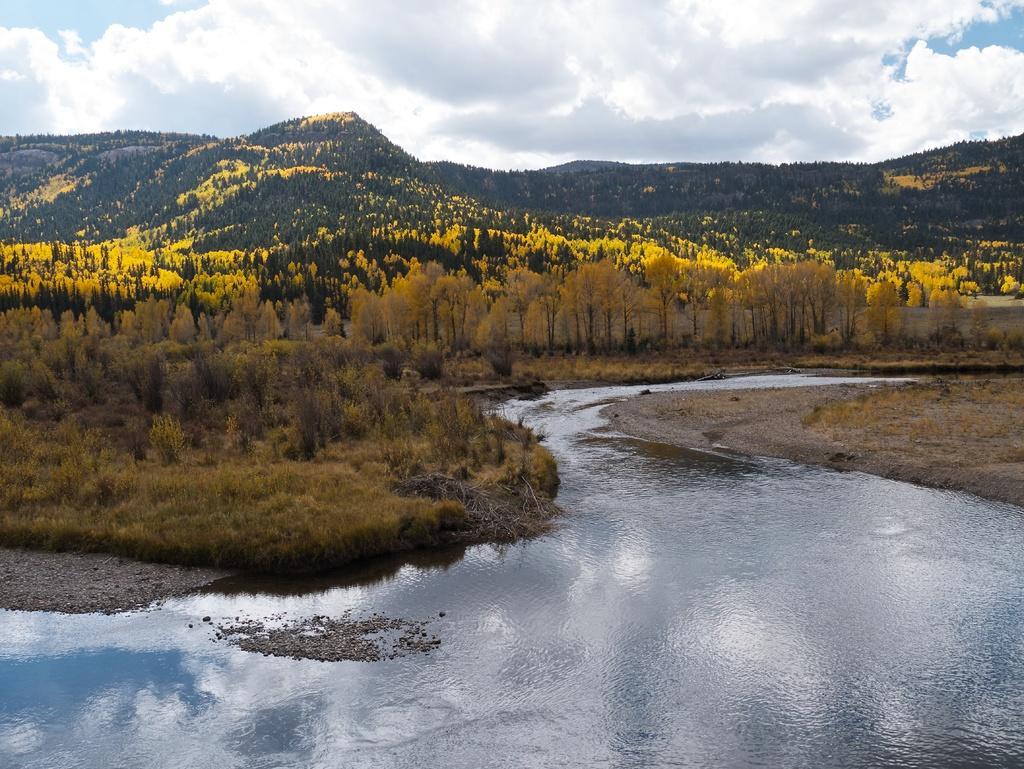How would you summarize this image in a sentence or two? In the picture we can see the water on either sides of the water we can see dried grass path and on one side we can see plants, trees and hills covered with trees and plants and behind it we can see a sky with clouds. 